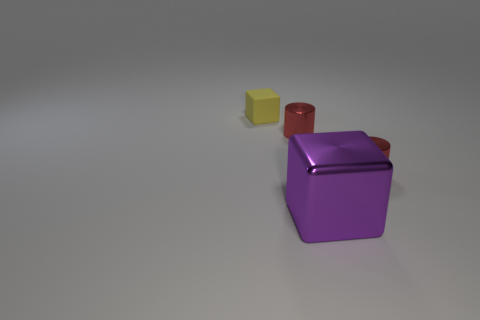Are there any other things that have the same size as the purple object?
Offer a very short reply. No. There is a block that is on the left side of the small red object to the left of the block that is in front of the tiny matte cube; what is it made of?
Your answer should be compact. Rubber. There is a cylinder that is to the right of the large purple metal cube; what is it made of?
Keep it short and to the point. Metal. Is there a red object that has the same size as the yellow matte block?
Make the answer very short. Yes. Do the cube that is behind the large purple metallic object and the big metal object have the same color?
Ensure brevity in your answer.  No. What number of yellow objects are either small cylinders or large blocks?
Provide a succinct answer. 0. How many tiny cylinders have the same color as the rubber cube?
Keep it short and to the point. 0. Do the big purple block and the tiny yellow block have the same material?
Offer a terse response. No. There is a small cylinder that is to the left of the large purple metallic cube; how many small metallic things are on the right side of it?
Make the answer very short. 1. Is the size of the yellow thing the same as the purple cube?
Keep it short and to the point. No. 